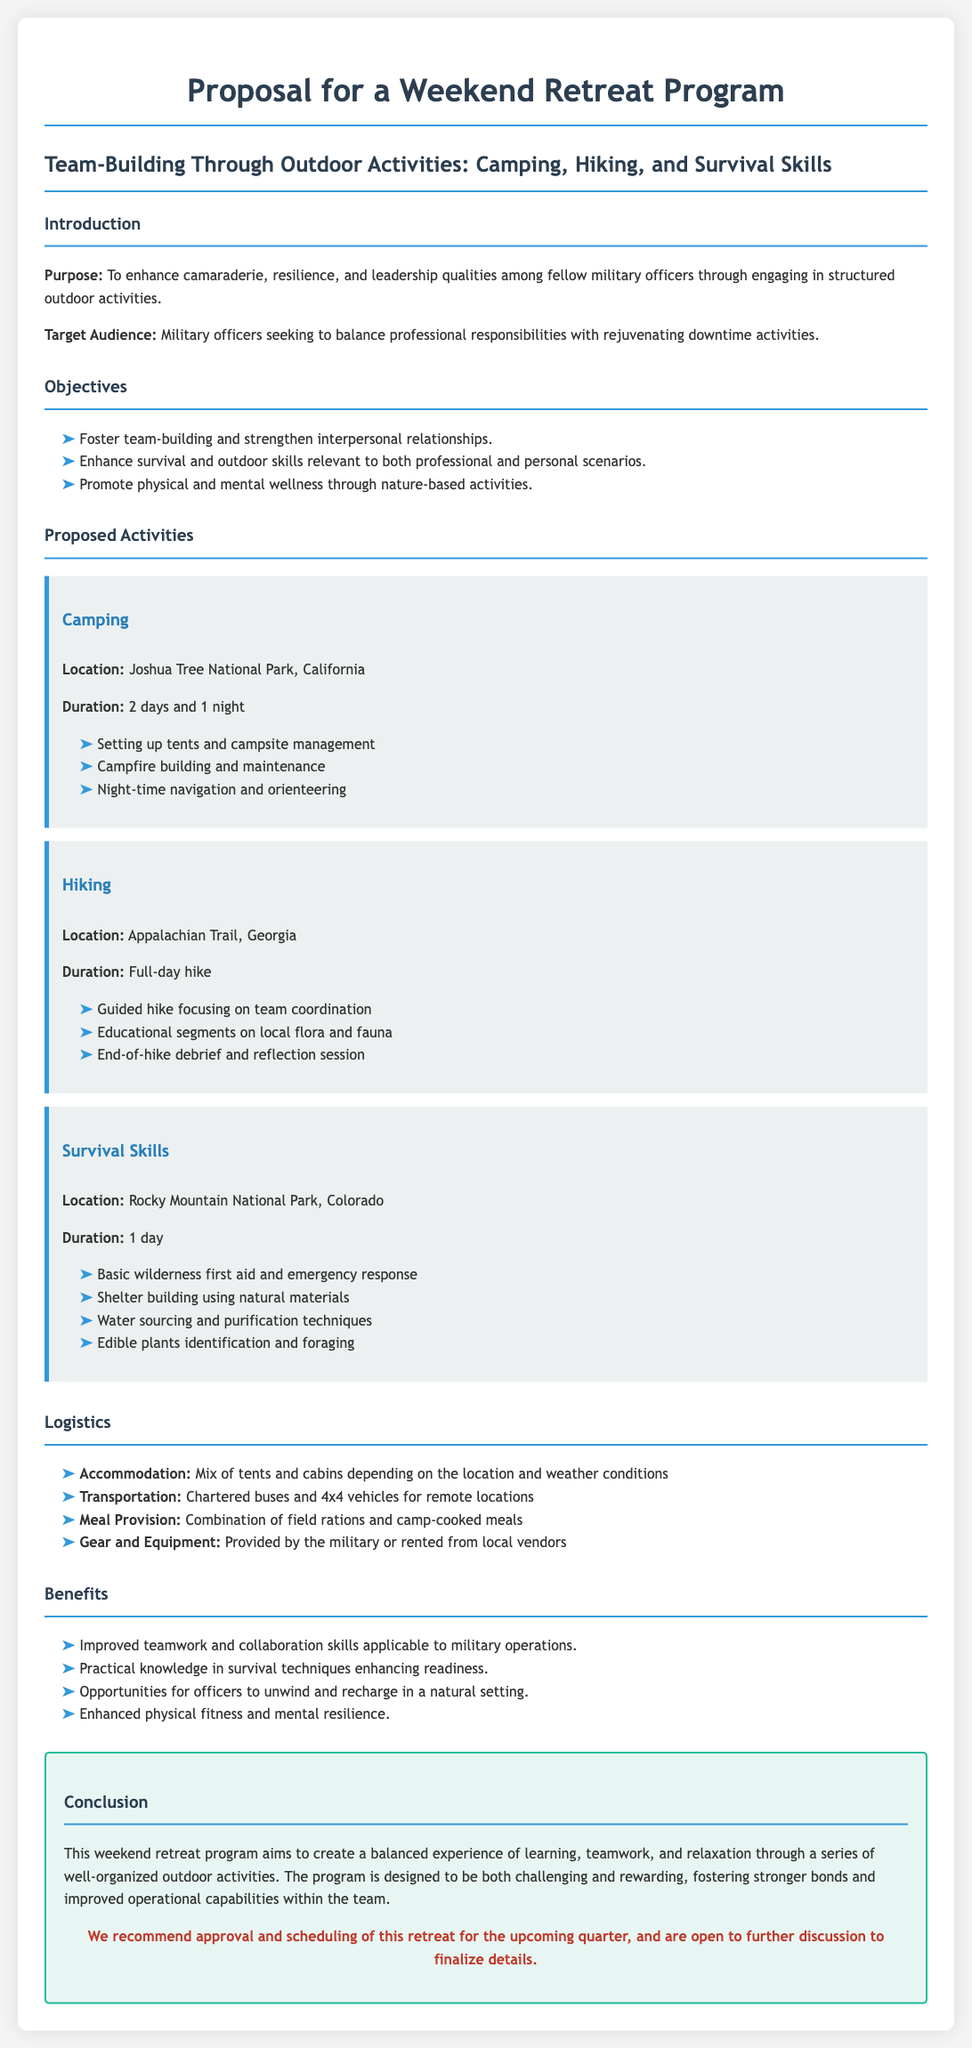What is the purpose of the retreat? The purpose is to enhance camaraderie, resilience, and leadership qualities among fellow military officers through engaging in structured outdoor activities.
Answer: Enhance camaraderie, resilience, and leadership qualities Who is the target audience for this program? The target audience is specified as military officers looking for rejuvenating downtime activities.
Answer: Military officers How many days and nights does the camping activity last? The document states that the camping activity lasts for 2 days and 1 night.
Answer: 2 days and 1 night What activity includes basic wilderness first aid? The activity that includes basic wilderness first aid is Survival Skills.
Answer: Survival Skills What is the location for the hiking activity? The location for the hiking activity is the Appalachian Trail, Georgia.
Answer: Appalachian Trail, Georgia Which outdoor activity has a guided component? The hiking activity includes a guided component focused on team coordination.
Answer: Hiking What type of accommodation is mentioned in the logistics section? The types of accommodation mentioned include a mix of tents and cabins.
Answer: Mix of tents and cabins What is a key benefit of the retreat program? A key benefit is improved teamwork and collaboration skills applicable to military operations.
Answer: Improved teamwork and collaboration skills What is the conclusion of the proposal emphasizing? The conclusion emphasizes creating a balanced experience of learning, teamwork, and relaxation.
Answer: Balanced experience of learning, teamwork, and relaxation 